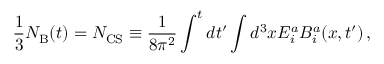<formula> <loc_0><loc_0><loc_500><loc_500>\frac { 1 } { 3 } N _ { B } ( t ) = N _ { C S } \equiv \frac { 1 } { 8 \pi ^ { 2 } } \int ^ { t } d t ^ { \prime } \int d ^ { 3 } x E _ { i } ^ { a } B _ { i } ^ { a } ( x , t ^ { \prime } ) \, ,</formula> 